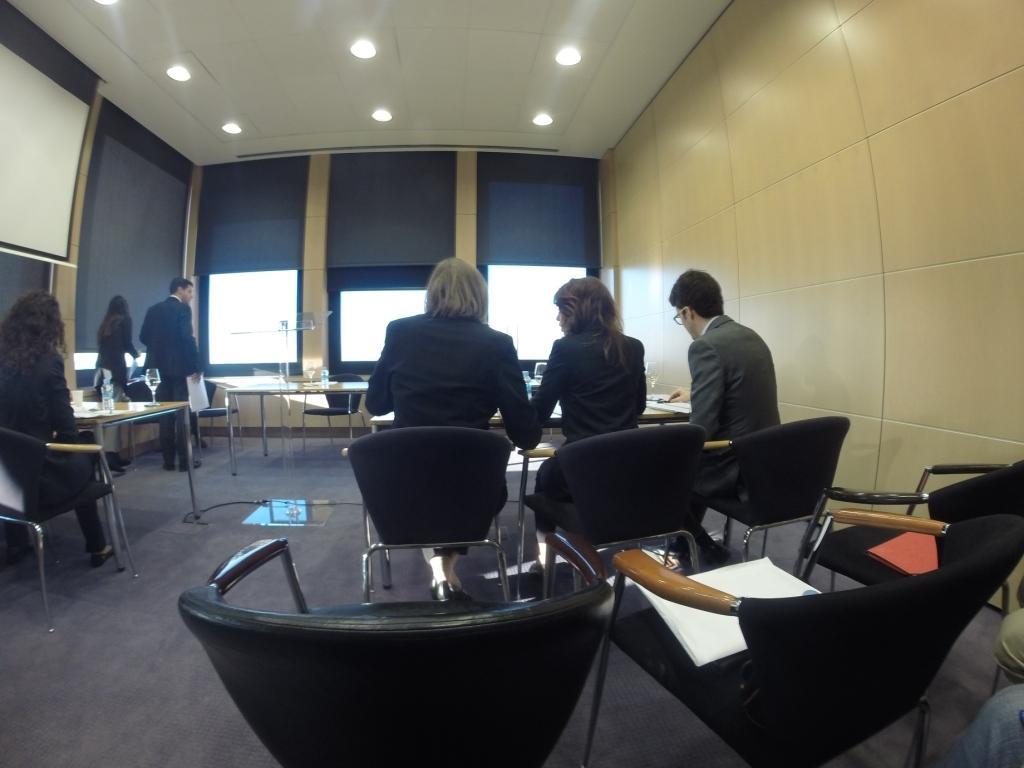In one or two sentences, can you explain what this image depicts? In this image there are group of persons who are sitting in the chair in a room and at the top of the image there are lights and at the left side of the image there is a white color sheet 